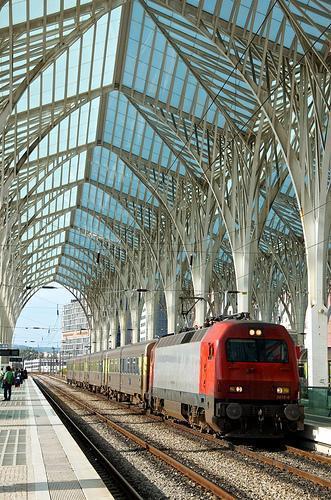How many trains are there?
Give a very brief answer. 1. 